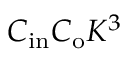<formula> <loc_0><loc_0><loc_500><loc_500>C _ { i n } C _ { o } K ^ { 3 }</formula> 